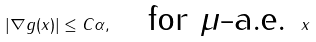Convert formula to latex. <formula><loc_0><loc_0><loc_500><loc_500>| \nabla g ( x ) | \leq C \alpha , \quad \text {for $\mu$-a.e. } x</formula> 